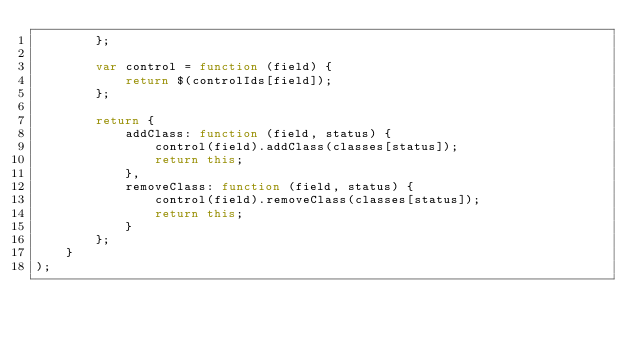<code> <loc_0><loc_0><loc_500><loc_500><_JavaScript_>        };

        var control = function (field) {
            return $(controlIds[field]);
        };

        return {
            addClass: function (field, status) {
                control(field).addClass(classes[status]);
                return this;
            },
            removeClass: function (field, status) {
                control(field).removeClass(classes[status]);
                return this;
            }
        };
    }
);
</code> 